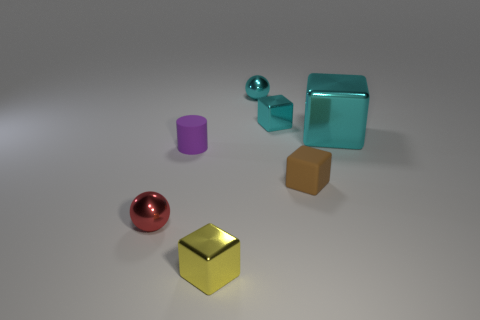Are there fewer metallic cubes than cyan metallic spheres?
Give a very brief answer. No. Is the size of the cyan sphere the same as the matte object that is on the right side of the yellow block?
Provide a short and direct response. Yes. Are there any other things that are the same shape as the tiny purple rubber object?
Provide a succinct answer. No. Are there fewer yellow things that are behind the large cyan shiny cube than large gray rubber things?
Provide a succinct answer. No. The big object that is the same material as the red ball is what color?
Your answer should be compact. Cyan. Is the number of rubber objects that are to the left of the tiny yellow metallic object less than the number of metallic things left of the big cyan shiny thing?
Your answer should be very brief. Yes. How many metal blocks are the same color as the large metallic thing?
Provide a succinct answer. 1. What is the material of the cube that is the same color as the big shiny object?
Your answer should be very brief. Metal. How many shiny objects are both on the right side of the red metallic thing and in front of the tiny brown object?
Provide a short and direct response. 1. What is the ball that is behind the small cube that is behind the large shiny cube made of?
Offer a terse response. Metal. 